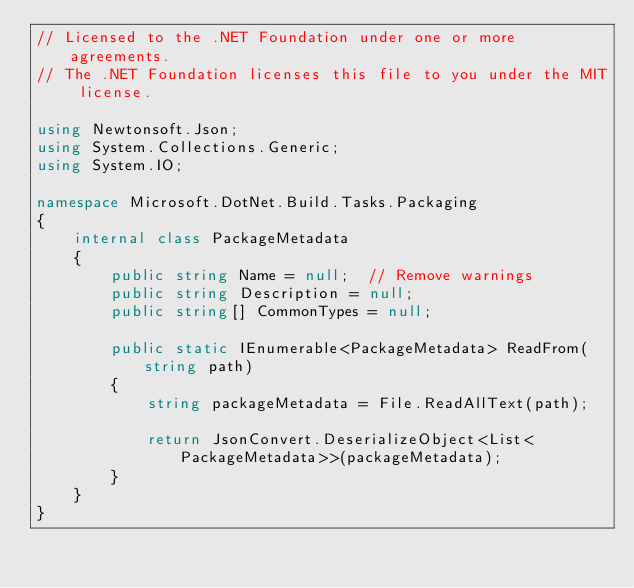<code> <loc_0><loc_0><loc_500><loc_500><_C#_>// Licensed to the .NET Foundation under one or more agreements.
// The .NET Foundation licenses this file to you under the MIT license.

using Newtonsoft.Json;
using System.Collections.Generic;
using System.IO;

namespace Microsoft.DotNet.Build.Tasks.Packaging
{
    internal class PackageMetadata
    {
        public string Name = null;  // Remove warnings
        public string Description = null;
        public string[] CommonTypes = null;

        public static IEnumerable<PackageMetadata> ReadFrom(string path)
        {
            string packageMetadata = File.ReadAllText(path);

            return JsonConvert.DeserializeObject<List<PackageMetadata>>(packageMetadata);
        }
    }
}
</code> 